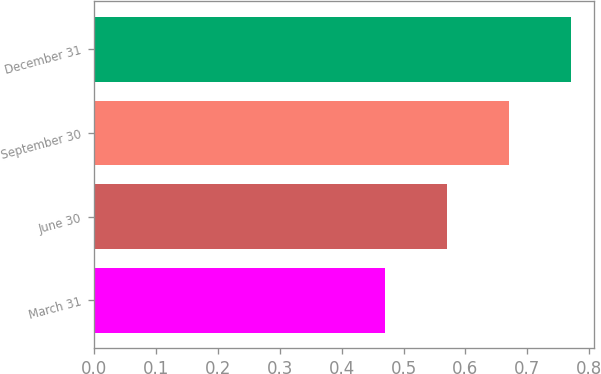<chart> <loc_0><loc_0><loc_500><loc_500><bar_chart><fcel>March 31<fcel>June 30<fcel>September 30<fcel>December 31<nl><fcel>0.47<fcel>0.57<fcel>0.67<fcel>0.77<nl></chart> 